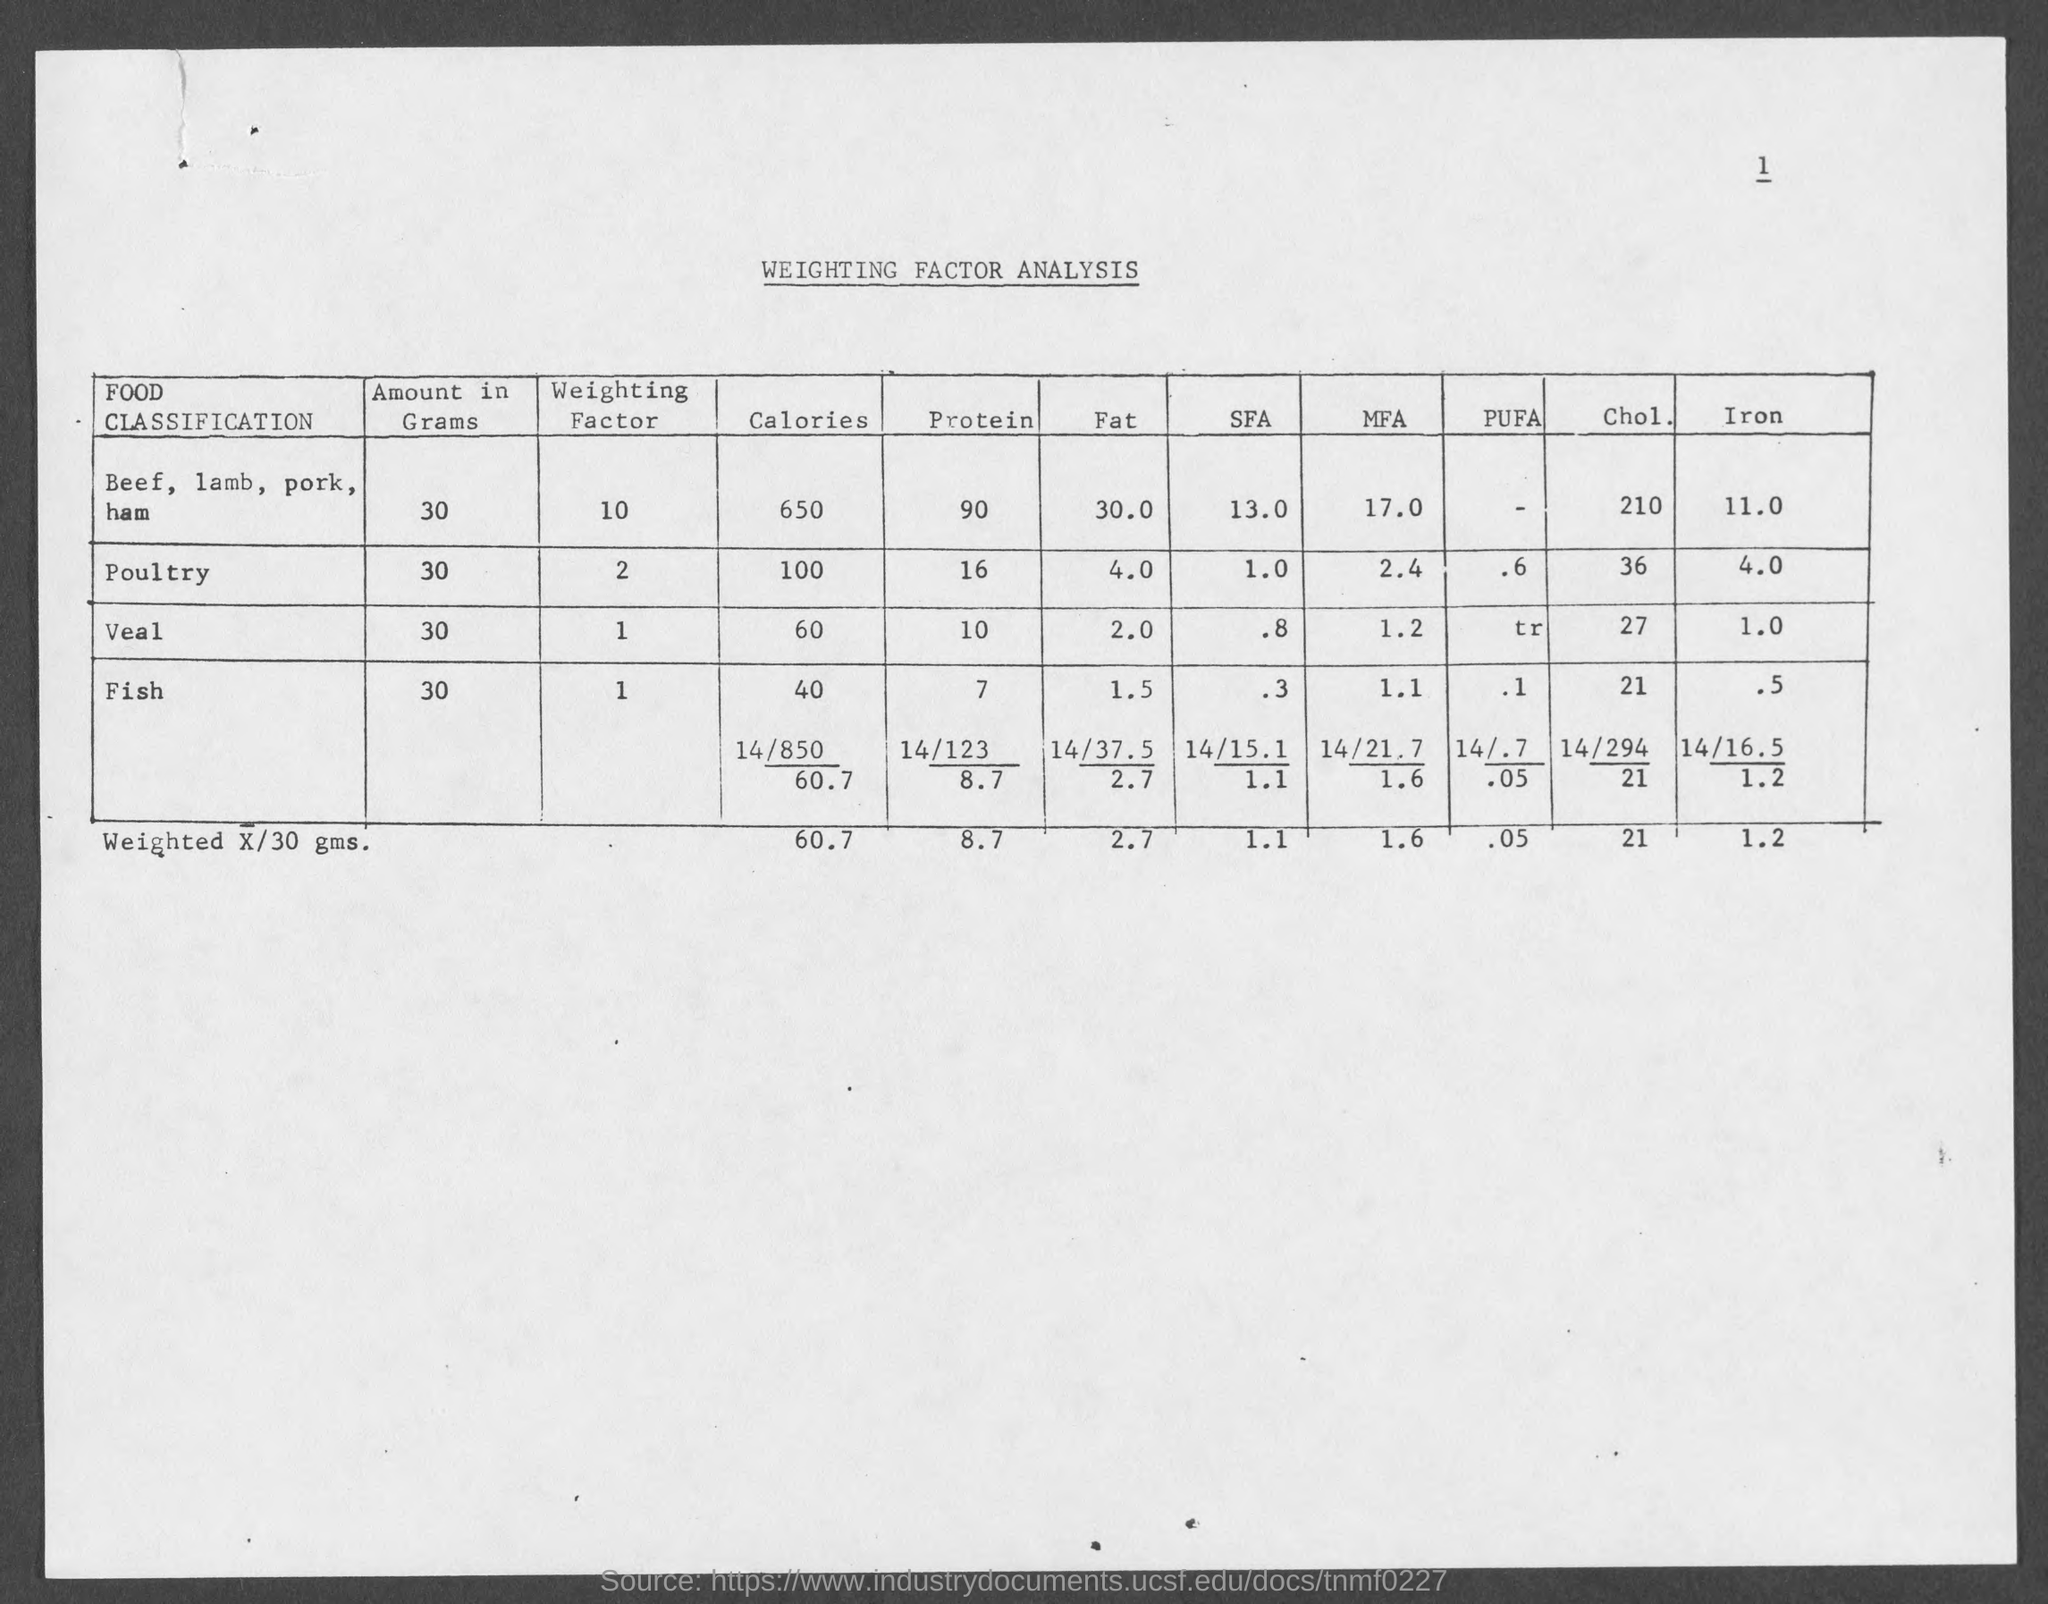What analysis report is provided?
Ensure brevity in your answer.  WEIGHTING FACTOR ANALYSIS. How much calories are there in 30 grams of Beef?
Offer a very short reply. 650 calories. How much Protein content is there in 30 grams of Veal?
Your answer should be compact. 10. How much Fat content is there in 30 grams of Veal?
Keep it short and to the point. 2. 